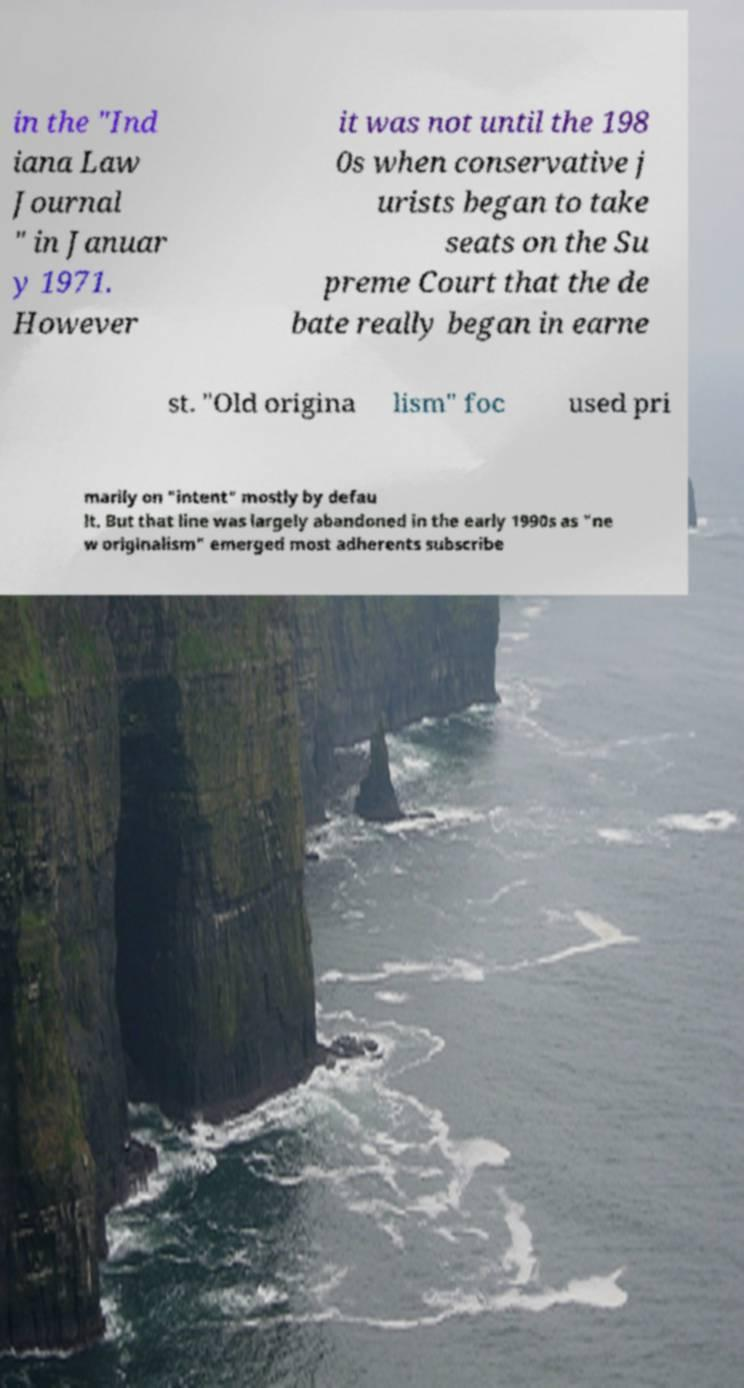There's text embedded in this image that I need extracted. Can you transcribe it verbatim? in the "Ind iana Law Journal " in Januar y 1971. However it was not until the 198 0s when conservative j urists began to take seats on the Su preme Court that the de bate really began in earne st. "Old origina lism" foc used pri marily on "intent" mostly by defau lt. But that line was largely abandoned in the early 1990s as "ne w originalism" emerged most adherents subscribe 